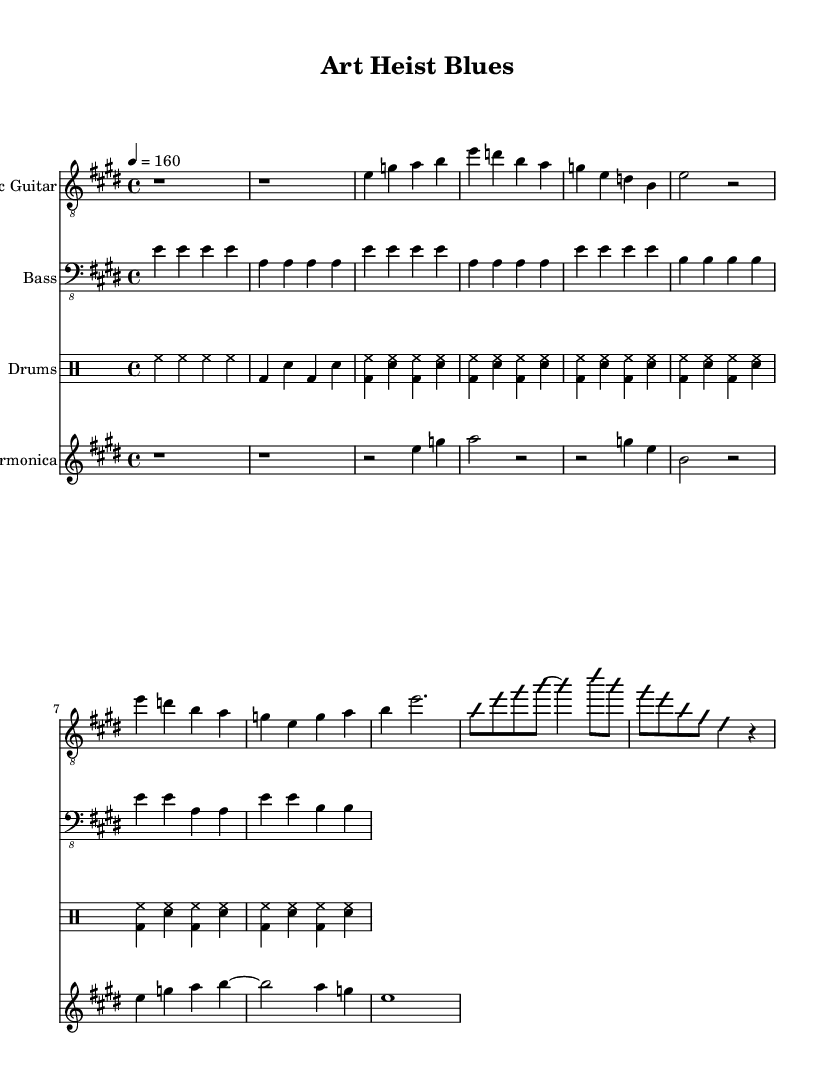What is the key signature of this music? The key signature indicates E major, which has four sharps (F#, C#, G#, and D#). This can be identified at the beginning of the score where the sharps are noted.
Answer: E major What is the time signature of this piece? The time signature is found at the beginning of the score, shown as 4/4, meaning there are four beats in each measure.
Answer: 4/4 What is the tempo marking for this music? The tempo is marked as 4 = 160, which indicates that there are 160 beats per minute. This can be deduced from the tempo instruction at the start of the score.
Answer: 160 How many measures are in the verse? The verse consists of two measures, which can be counted from the music lines indicating notes within the section labeled "Verse 1".
Answer: 2 What type of improvisation does the guitar perform? The guitar part indicates an improvisation section, specifically noted with "improvisationOn" and "improvisationOff". This shows that it is a spontaneous musical phrase typical in electric blues.
Answer: Improvisation What instrument is mainly responsible for the call and response in the verse? The harmonica part includes specific call and response motifs, characterized by the alternating notes played against the main melody in the verse, as indicated in the harmonica section.
Answer: Harmonica How does the rhythm section support the overall energy of the piece? The rhythm section, particularly the drums and bass, consistently use patterns that drive the piece forward, creating a high-energy feel typical of electric blues. The drum part shows strong accents and syncopations, enhancing the thrill of the music.
Answer: Strong accents 